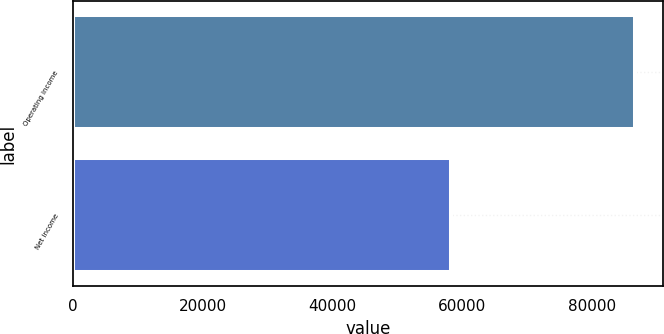Convert chart to OTSL. <chart><loc_0><loc_0><loc_500><loc_500><bar_chart><fcel>Operating income<fcel>Net income<nl><fcel>86550<fcel>58301<nl></chart> 